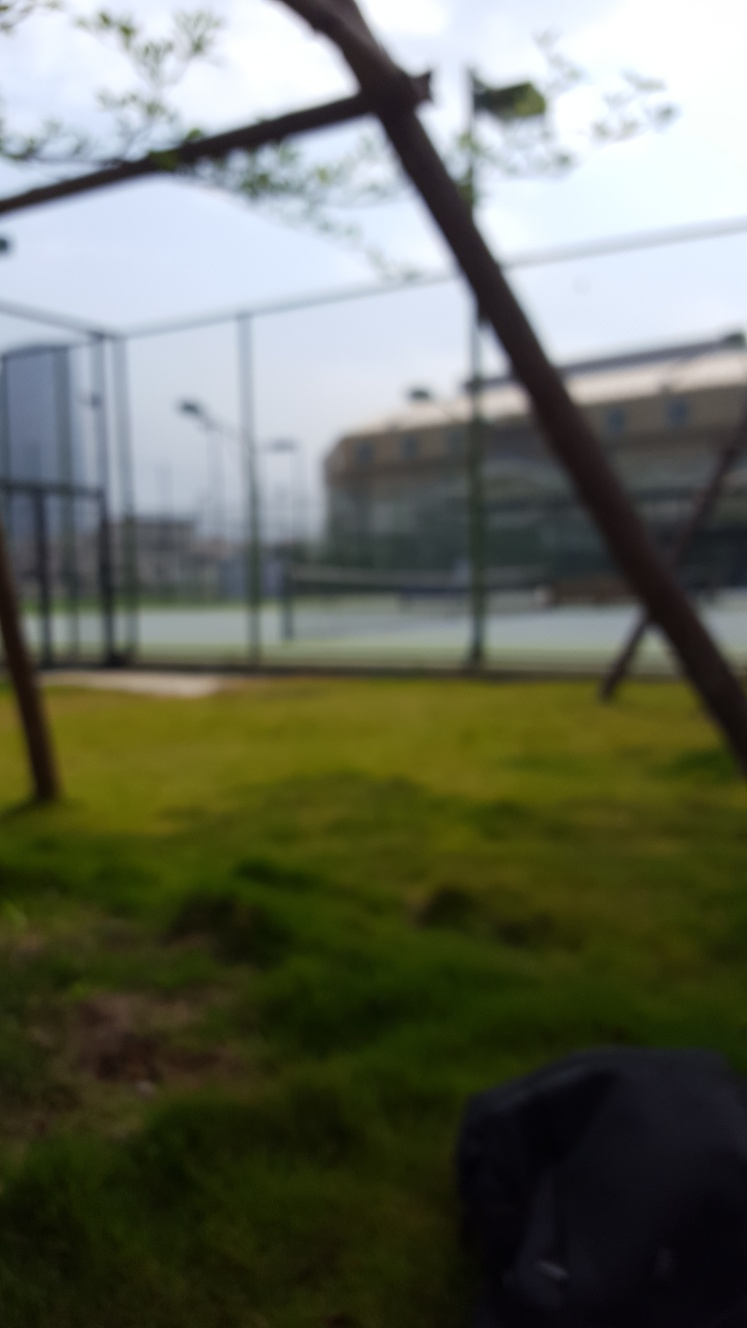What objects can you identify in this blurry image? Identifying specific objects in this blurred image is challenging. There is an indistinct object in the foreground that could be a bag or dark-colored item resting on the grass, and the vertical elements might be trees or posts. The blurred state of the picture complicates precise identification. 